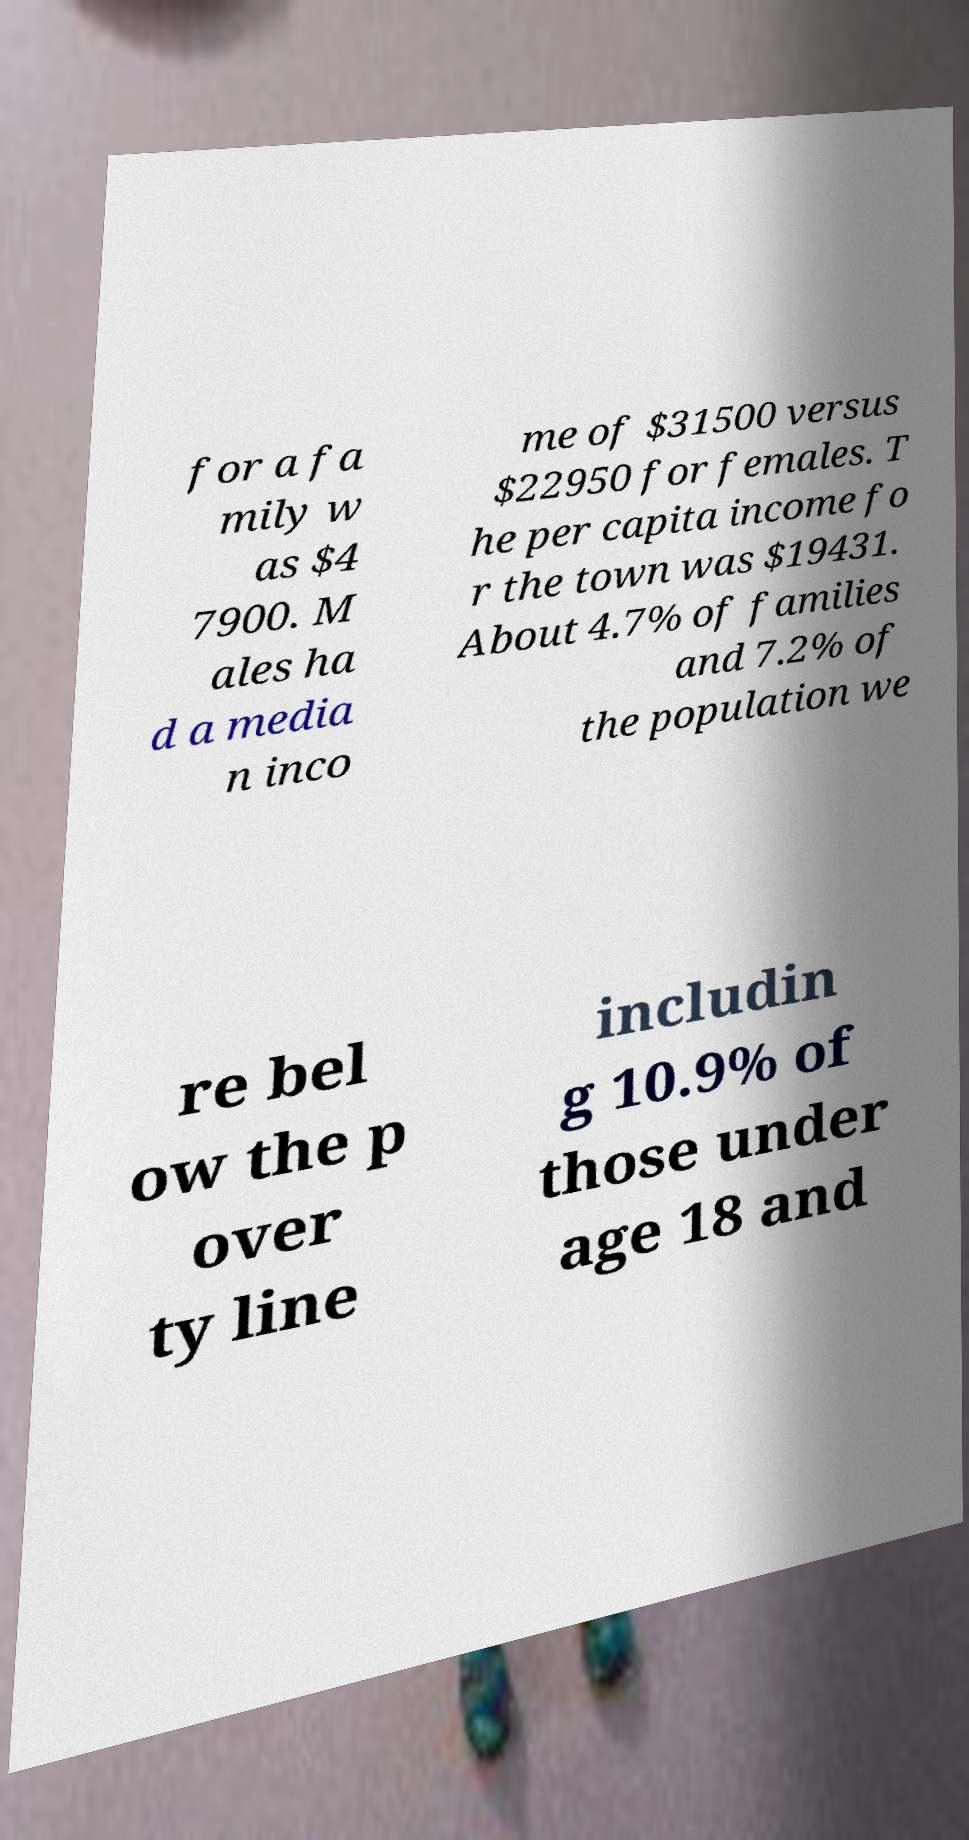For documentation purposes, I need the text within this image transcribed. Could you provide that? for a fa mily w as $4 7900. M ales ha d a media n inco me of $31500 versus $22950 for females. T he per capita income fo r the town was $19431. About 4.7% of families and 7.2% of the population we re bel ow the p over ty line includin g 10.9% of those under age 18 and 